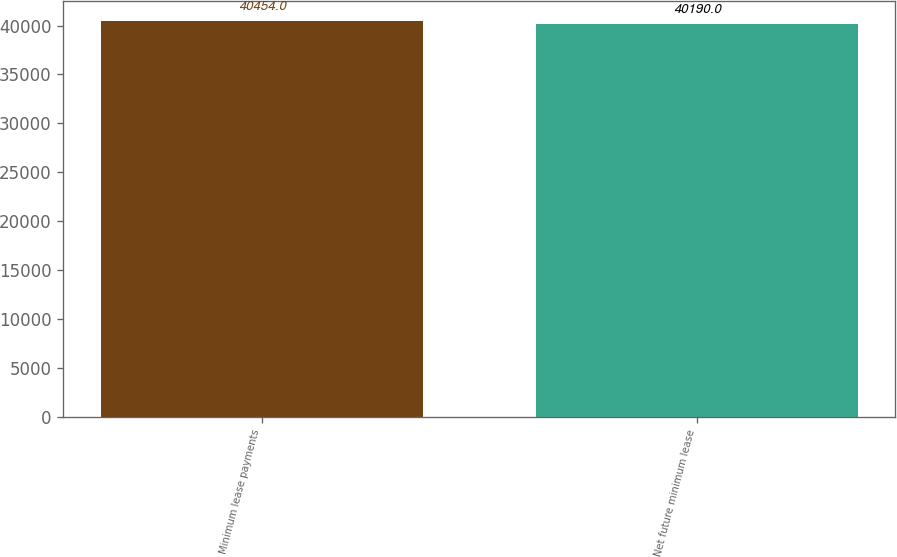Convert chart to OTSL. <chart><loc_0><loc_0><loc_500><loc_500><bar_chart><fcel>Minimum lease payments<fcel>Net future minimum lease<nl><fcel>40454<fcel>40190<nl></chart> 